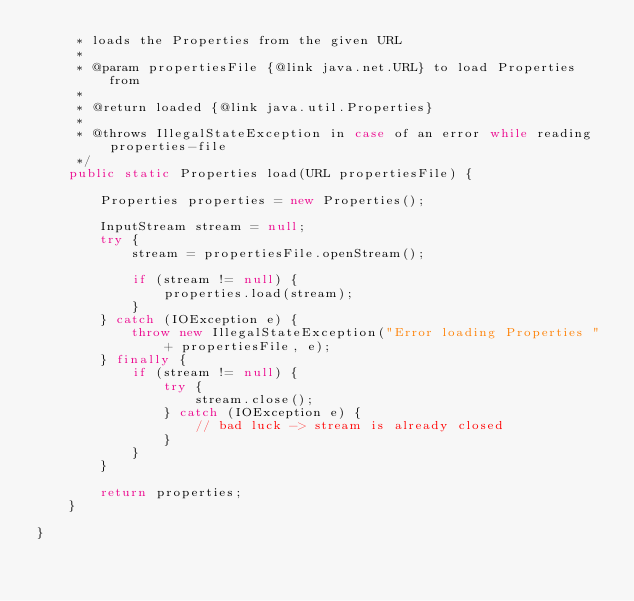Convert code to text. <code><loc_0><loc_0><loc_500><loc_500><_Java_>     * loads the Properties from the given URL
     *
     * @param propertiesFile {@link java.net.URL} to load Properties from
     *
     * @return loaded {@link java.util.Properties}
     *
     * @throws IllegalStateException in case of an error while reading properties-file
     */
    public static Properties load(URL propertiesFile) {

        Properties properties = new Properties();

        InputStream stream = null;
        try {
            stream = propertiesFile.openStream();

            if (stream != null) {
                properties.load(stream);
            }
        } catch (IOException e) {
            throw new IllegalStateException("Error loading Properties " + propertiesFile, e);
        } finally {
            if (stream != null) {
                try {
                    stream.close();
                } catch (IOException e) {
                    // bad luck -> stream is already closed
                }
            }
        }

        return properties;
    }

}
</code> 